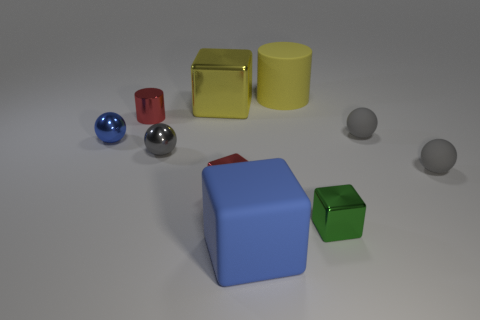Are there any other things that have the same size as the green metallic cube?
Keep it short and to the point. Yes. Are there the same number of big yellow blocks that are left of the large blue matte block and purple matte cylinders?
Offer a terse response. No. What is the shape of the tiny green thing?
Offer a very short reply. Cube. Are there any other things that have the same color as the small shiny cylinder?
Keep it short and to the point. Yes. There is a block behind the small blue sphere; is it the same size as the gray object that is behind the gray shiny object?
Ensure brevity in your answer.  No. What shape is the tiny gray thing that is on the left side of the big cube that is in front of the red block?
Ensure brevity in your answer.  Sphere. There is a green shiny cube; is its size the same as the blue thing in front of the small green thing?
Keep it short and to the point. No. There is a yellow shiny cube that is behind the small metallic block to the left of the large object that is behind the yellow cube; what size is it?
Provide a succinct answer. Large. What number of objects are either metal things on the left side of the green metal thing or tiny gray matte balls?
Offer a terse response. 7. There is a large blue matte thing right of the small blue ball; what number of tiny metallic blocks are right of it?
Your response must be concise. 1. 